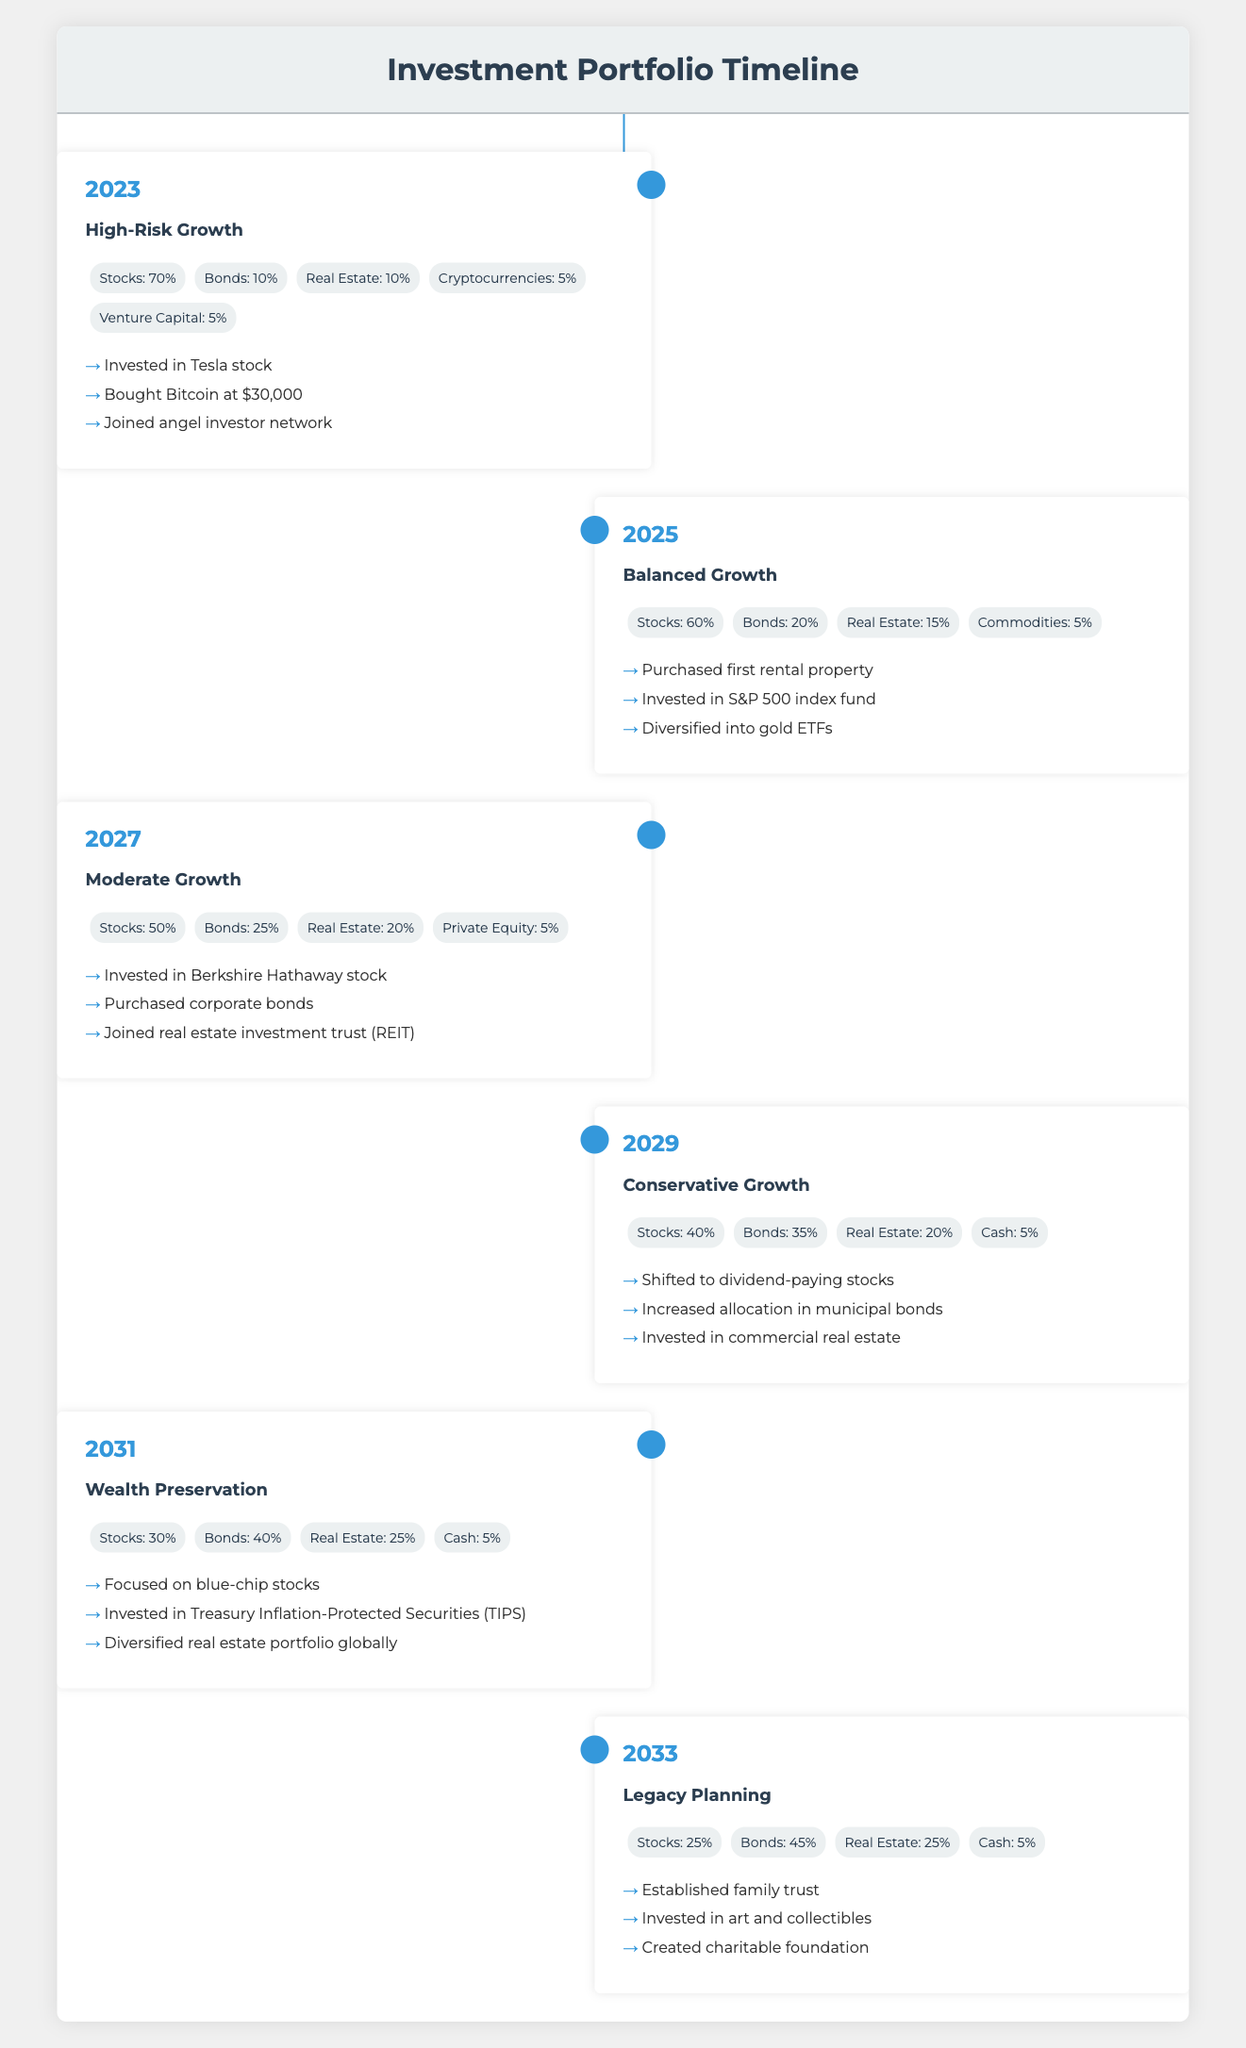What is the allocation percentage for Stocks in 2025? In the year 2025, the allocation is listed as Stocks: 60%.
Answer: 60% Which year had the highest percentage allocated to Bonds? The year 2033 shows the highest allocation for Bonds at 45%.
Answer: 2033 What is the average percentage allocated to Real Estate from 2023 to 2033? The allocations are 10% (2023), 15% (2025), 20% (2027), 20% (2029), 25% (2031), and 25% (2033). To find the average, we calculate: (10 + 15 + 20 + 20 + 25 + 25) / 6 = 115 / 6 = 19.17%, rounded to two decimal places.
Answer: 19.17% Did the allocation for Cryptocurrencies increase from 2023 to 2025? In 2023, the allocation for Cryptocurrencies was 5%, but in 2025, it is no longer mentioned, indicating it went to 0%. Therefore, the allocation did decrease.
Answer: Yes Which stage has the lowest allocation in Stocks? By reviewing the stages, the lowest allocation in Stocks is found in the 2033 stage with 25%.
Answer: 2033 What changes occurred in the allocation of Bonds from 2027 to 2031? In 2027, the allocation for Bonds was 25%, and by 2031 it had risen to 40%. To determine the change, we subtract: 40% - 25% = 15%. Therefore, Bonds increased by 15%.
Answer: Increased by 15% Is the allocation to Real Estate greater than the allocation to Cash in the year 2029? The allocation to Real Estate in 2029 is 20%, while the allocation to Cash is 5%. Since 20% is greater than 5%, the statement is true.
Answer: Yes How did the allocation strategy change from High-Risk Growth to Conservative Growth? In High-Risk Growth (2023), the allocation was 70% in Stocks, 10% in Bonds, 10% in Real Estate, 5% in Cryptocurrencies, and 5% in Venture Capital. In Conservative Growth (2029), it shifted to 40% in Stocks, 35% in Bonds, 20% in Real Estate, and 5% in Cash. This shows a clear decrease in Stocks and an increase in Bonds.
Answer: Decreased Stocks and increased Bonds What key events occurred during the Moderate Growth stage? For the Moderate Growth stage in 2027, the key events listed are investing in Berkshire Hathaway stock, purchasing corporate bonds, and joining a real estate investment trust (REIT).
Answer: Invested in Berkshire Hathaway stock, purchased corporate bonds, joined REIT 